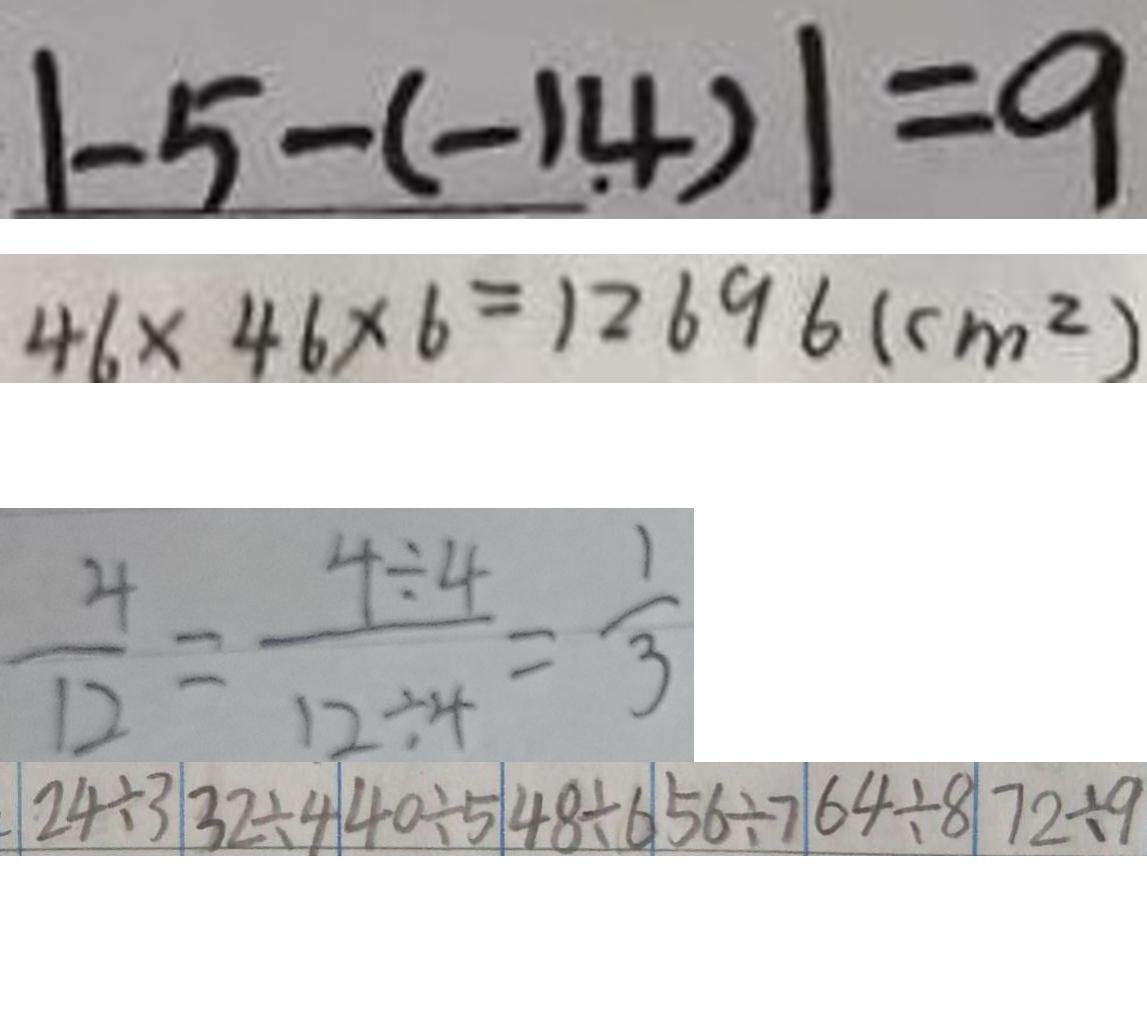<formula> <loc_0><loc_0><loc_500><loc_500>\vert - 5 - ( - 1 . 4 ) \vert = 9 
 4 6 \times 4 6 \times 6 = 1 2 6 9 6 ( c m ^ { 2 } ) 
 \frac { 4 } { 1 2 } = \frac { 4 \div 4 } { 1 2 \div 4 } = \frac { 1 } { 3 } 
 \vert 2 4 \div 3 \vert 3 2 \div 4 \vert 4 0 \div 5 \vert 4 8 \div 6 \vert 5 6 \div 7 \vert 6 4 \div 8 \vert 7 2 \div 9</formula> 